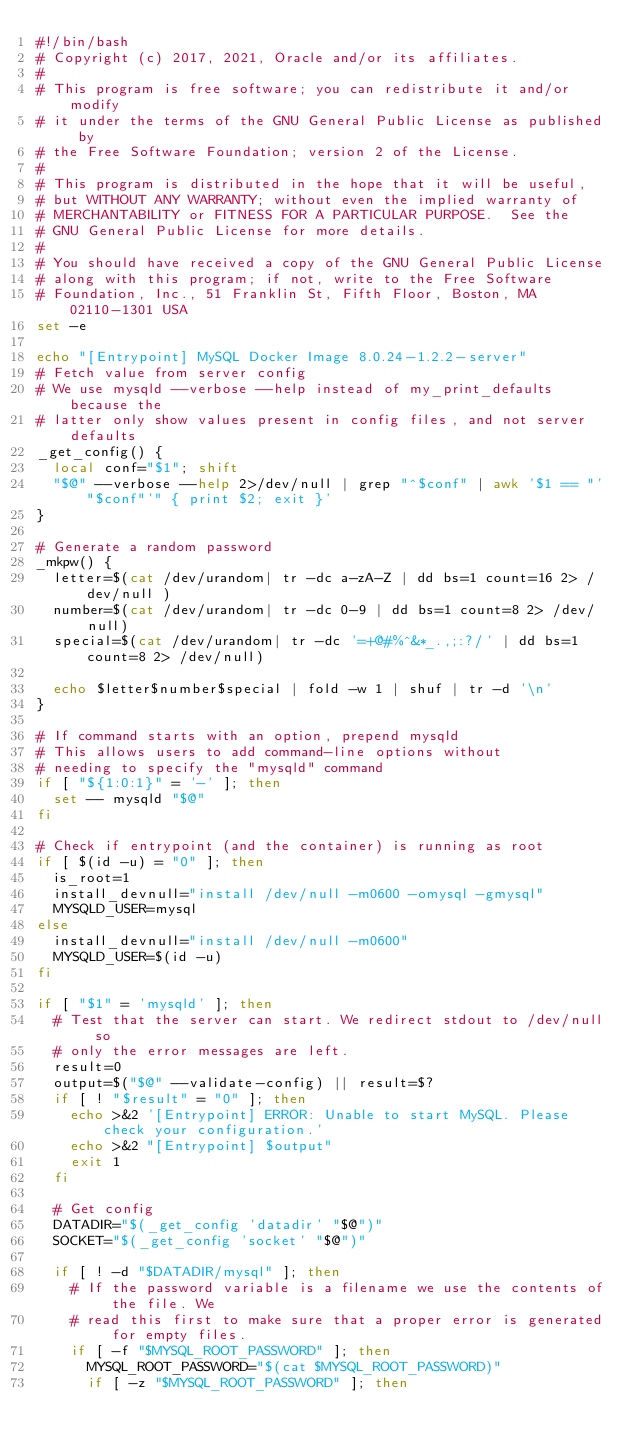<code> <loc_0><loc_0><loc_500><loc_500><_Bash_>#!/bin/bash
# Copyright (c) 2017, 2021, Oracle and/or its affiliates.
#
# This program is free software; you can redistribute it and/or modify
# it under the terms of the GNU General Public License as published by
# the Free Software Foundation; version 2 of the License.
#
# This program is distributed in the hope that it will be useful,
# but WITHOUT ANY WARRANTY; without even the implied warranty of
# MERCHANTABILITY or FITNESS FOR A PARTICULAR PURPOSE.  See the
# GNU General Public License for more details.
#
# You should have received a copy of the GNU General Public License
# along with this program; if not, write to the Free Software
# Foundation, Inc., 51 Franklin St, Fifth Floor, Boston, MA  02110-1301 USA
set -e

echo "[Entrypoint] MySQL Docker Image 8.0.24-1.2.2-server"
# Fetch value from server config
# We use mysqld --verbose --help instead of my_print_defaults because the
# latter only show values present in config files, and not server defaults
_get_config() {
	local conf="$1"; shift
	"$@" --verbose --help 2>/dev/null | grep "^$conf" | awk '$1 == "'"$conf"'" { print $2; exit }'
}

# Generate a random password
_mkpw() {
	letter=$(cat /dev/urandom| tr -dc a-zA-Z | dd bs=1 count=16 2> /dev/null )
	number=$(cat /dev/urandom| tr -dc 0-9 | dd bs=1 count=8 2> /dev/null)
	special=$(cat /dev/urandom| tr -dc '=+@#%^&*_.,;:?/' | dd bs=1 count=8 2> /dev/null)

	echo $letter$number$special | fold -w 1 | shuf | tr -d '\n'
}

# If command starts with an option, prepend mysqld
# This allows users to add command-line options without
# needing to specify the "mysqld" command
if [ "${1:0:1}" = '-' ]; then
	set -- mysqld "$@"
fi

# Check if entrypoint (and the container) is running as root
if [ $(id -u) = "0" ]; then
	is_root=1
	install_devnull="install /dev/null -m0600 -omysql -gmysql"
	MYSQLD_USER=mysql
else
	install_devnull="install /dev/null -m0600"
	MYSQLD_USER=$(id -u)
fi

if [ "$1" = 'mysqld' ]; then
	# Test that the server can start. We redirect stdout to /dev/null so
	# only the error messages are left.
	result=0
	output=$("$@" --validate-config) || result=$?
	if [ ! "$result" = "0" ]; then
		echo >&2 '[Entrypoint] ERROR: Unable to start MySQL. Please check your configuration.'
		echo >&2 "[Entrypoint] $output"
		exit 1
	fi

	# Get config
	DATADIR="$(_get_config 'datadir' "$@")"
	SOCKET="$(_get_config 'socket' "$@")"

	if [ ! -d "$DATADIR/mysql" ]; then
		# If the password variable is a filename we use the contents of the file. We
		# read this first to make sure that a proper error is generated for empty files.
		if [ -f "$MYSQL_ROOT_PASSWORD" ]; then
			MYSQL_ROOT_PASSWORD="$(cat $MYSQL_ROOT_PASSWORD)"
			if [ -z "$MYSQL_ROOT_PASSWORD" ]; then</code> 